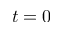<formula> <loc_0><loc_0><loc_500><loc_500>t = 0</formula> 